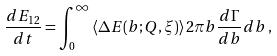<formula> <loc_0><loc_0><loc_500><loc_500>\frac { d E _ { 1 2 } } { d t } = \int _ { 0 } ^ { \infty } \left \langle \Delta E ( b ; Q , \xi ) \right \rangle 2 \pi b \frac { d \Gamma } { d b } d b \, ,</formula> 